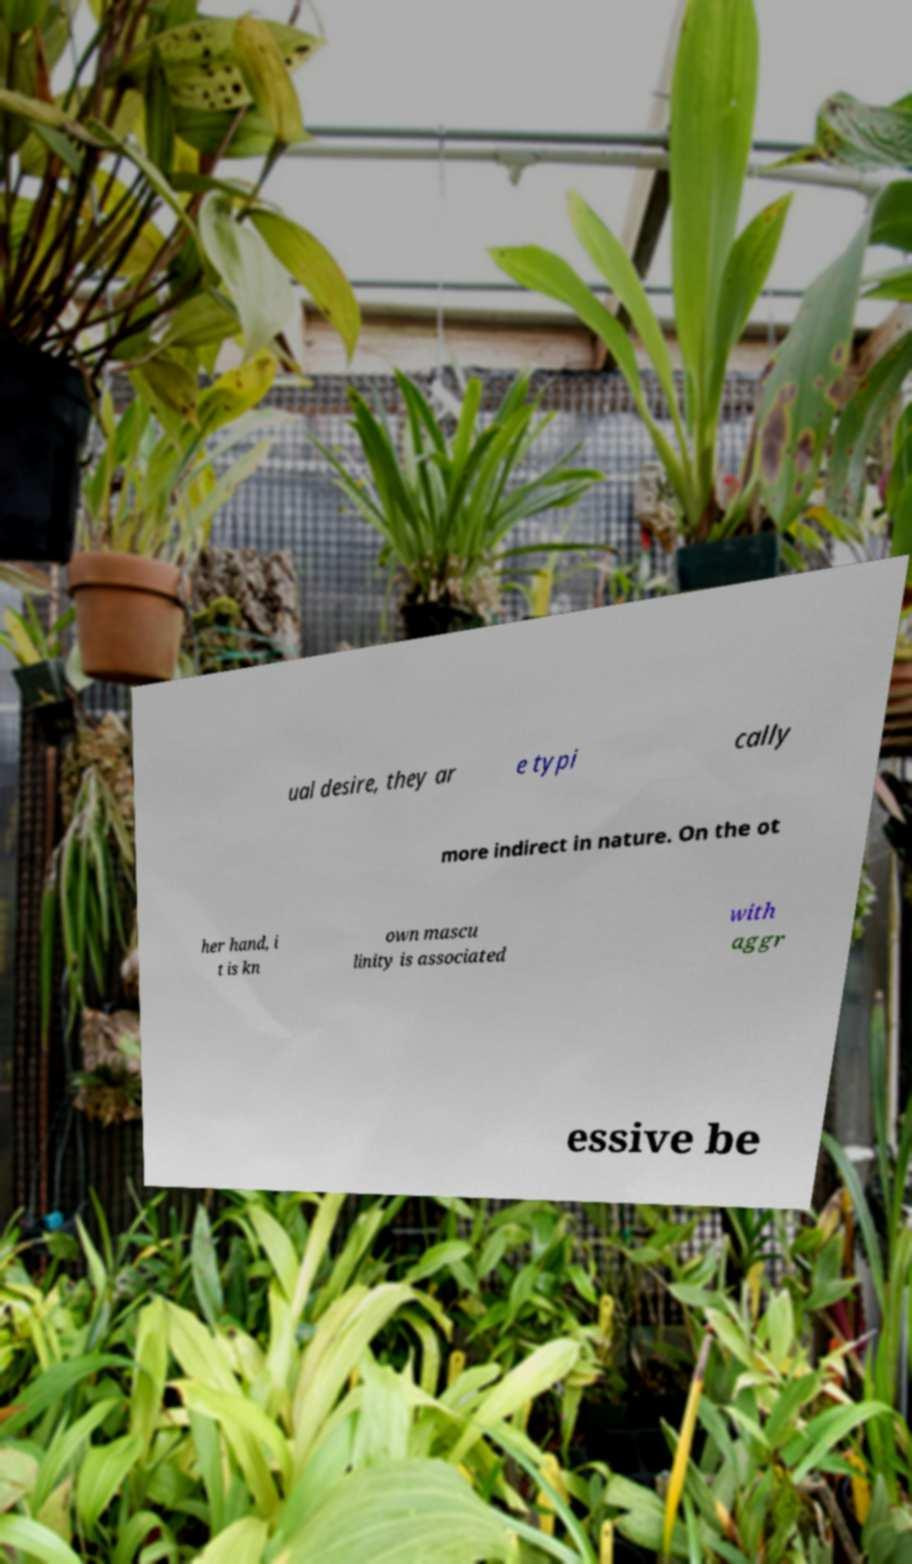There's text embedded in this image that I need extracted. Can you transcribe it verbatim? ual desire, they ar e typi cally more indirect in nature. On the ot her hand, i t is kn own mascu linity is associated with aggr essive be 